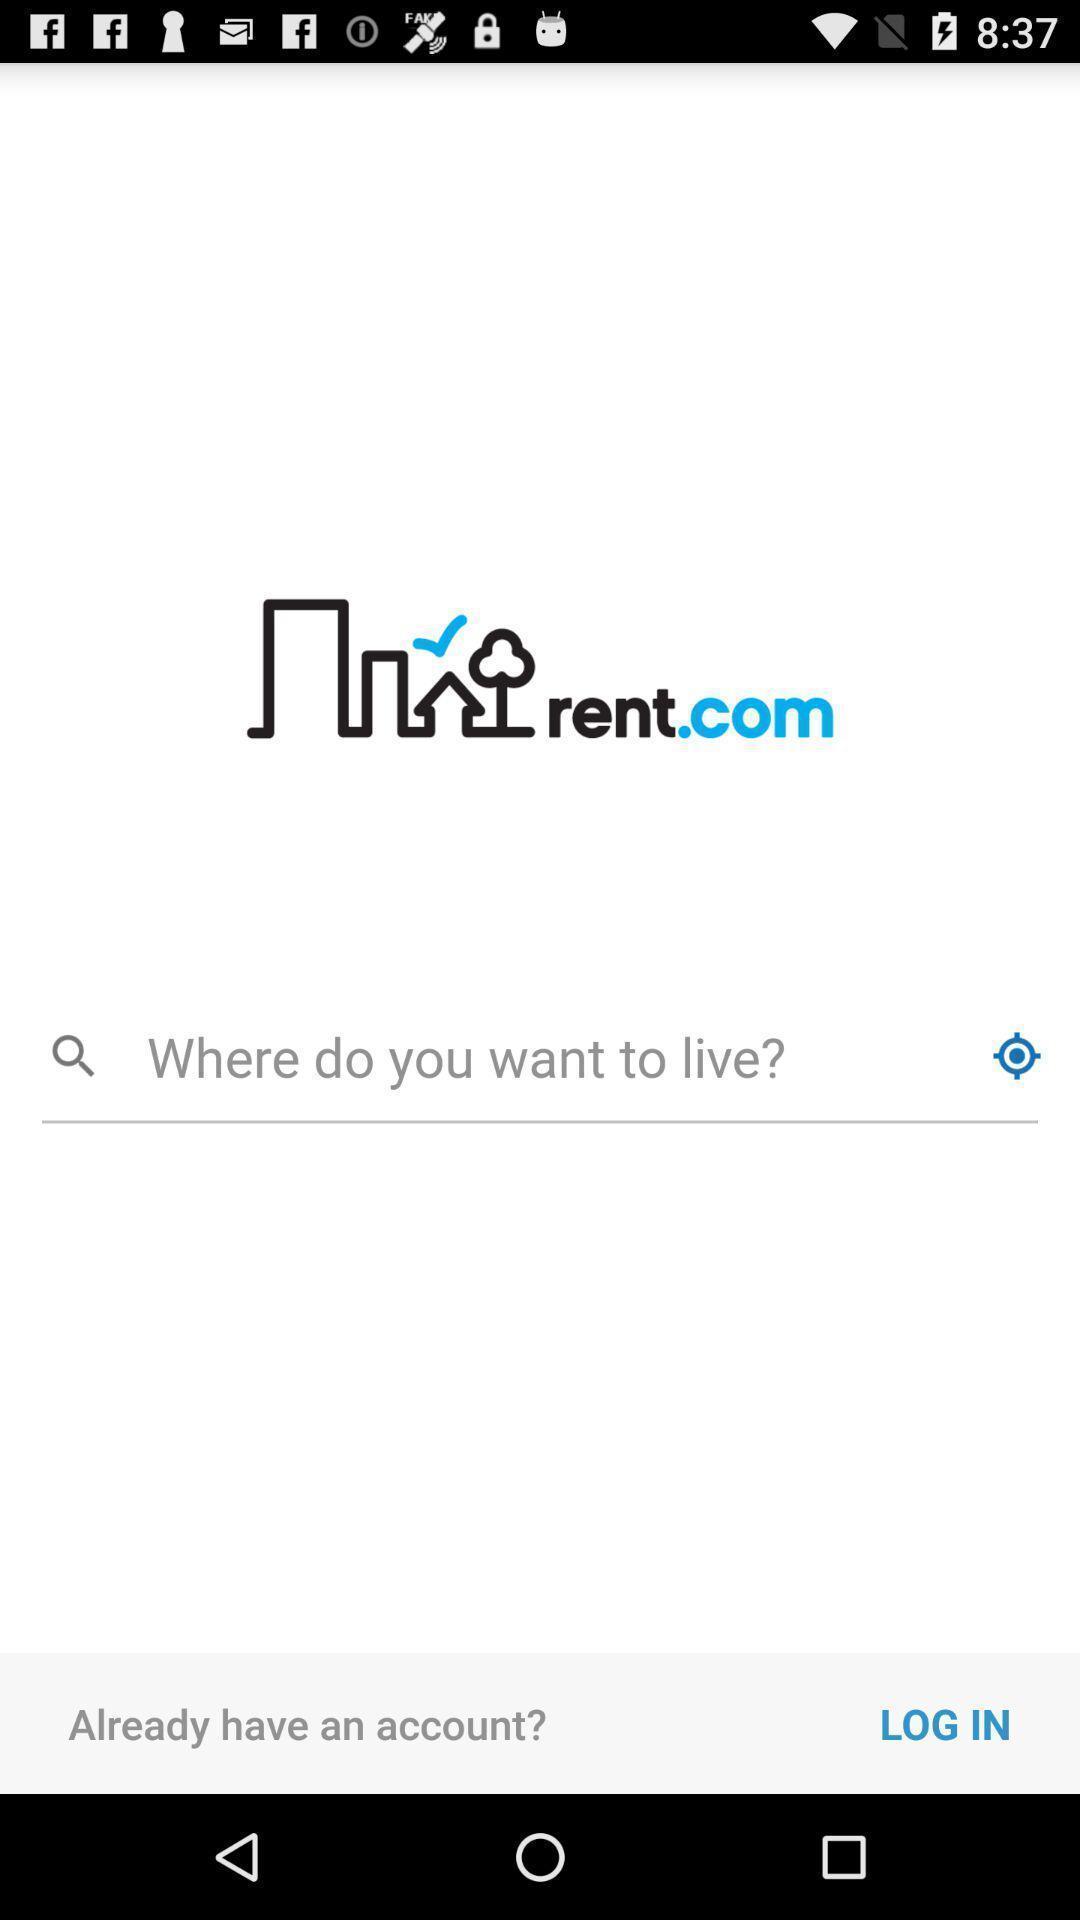Please provide a description for this image. Welcome page of the app. 